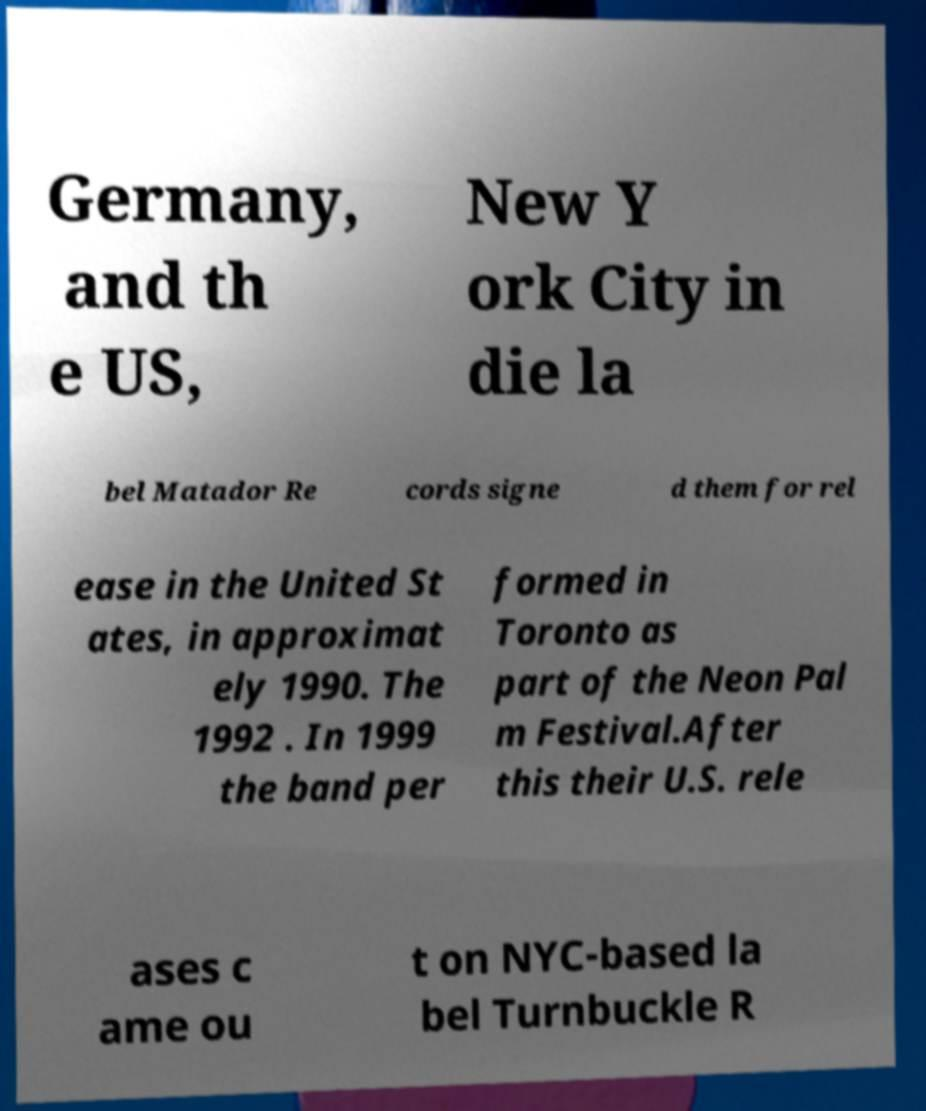For documentation purposes, I need the text within this image transcribed. Could you provide that? Germany, and th e US, New Y ork City in die la bel Matador Re cords signe d them for rel ease in the United St ates, in approximat ely 1990. The 1992 . In 1999 the band per formed in Toronto as part of the Neon Pal m Festival.After this their U.S. rele ases c ame ou t on NYC-based la bel Turnbuckle R 